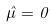Convert formula to latex. <formula><loc_0><loc_0><loc_500><loc_500>\hat { \mu } = 0</formula> 